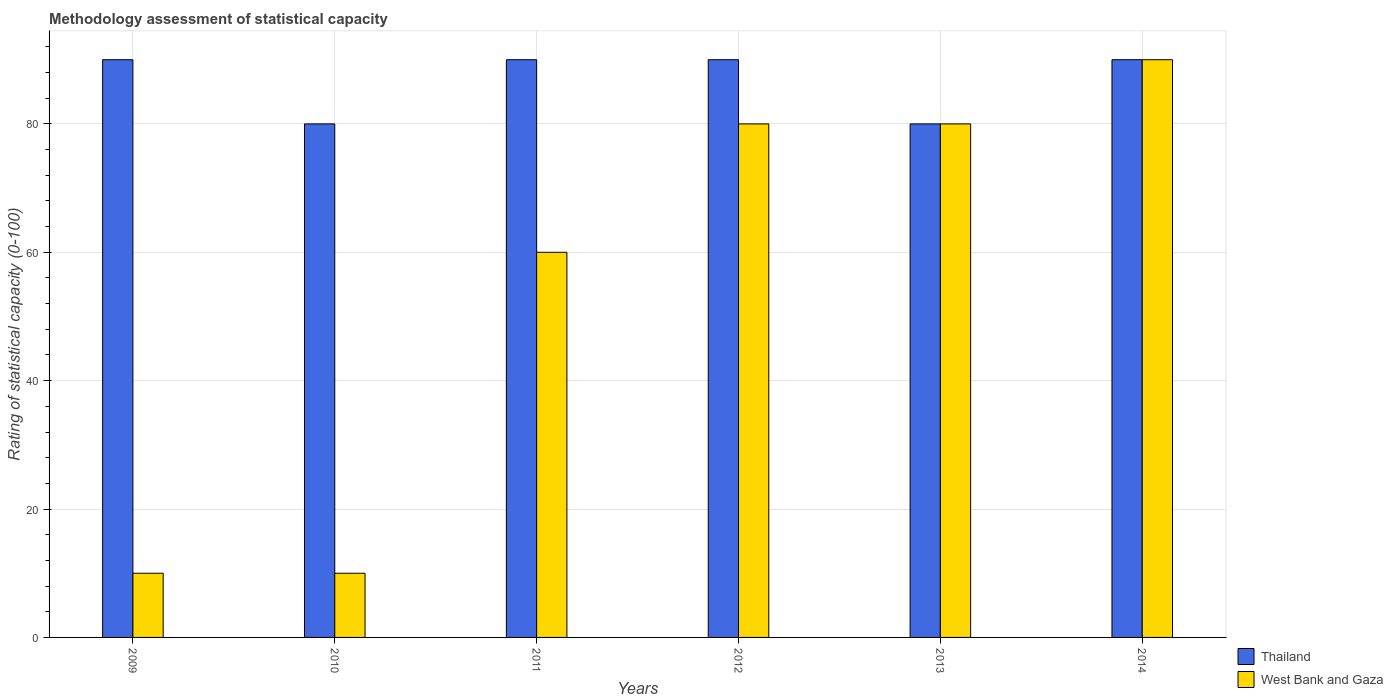Are the number of bars on each tick of the X-axis equal?
Provide a succinct answer. Yes. How many bars are there on the 2nd tick from the right?
Your answer should be very brief. 2. What is the label of the 6th group of bars from the left?
Keep it short and to the point. 2014. In how many cases, is the number of bars for a given year not equal to the number of legend labels?
Keep it short and to the point. 0. Across all years, what is the maximum rating of statistical capacity in West Bank and Gaza?
Provide a succinct answer. 90. Across all years, what is the minimum rating of statistical capacity in Thailand?
Your response must be concise. 80. In which year was the rating of statistical capacity in West Bank and Gaza maximum?
Ensure brevity in your answer.  2014. In which year was the rating of statistical capacity in Thailand minimum?
Provide a short and direct response. 2010. What is the total rating of statistical capacity in Thailand in the graph?
Make the answer very short. 520. What is the difference between the rating of statistical capacity in West Bank and Gaza in 2009 and that in 2013?
Give a very brief answer. -70. What is the ratio of the rating of statistical capacity in West Bank and Gaza in 2009 to that in 2011?
Provide a short and direct response. 0.17. Is the difference between the rating of statistical capacity in Thailand in 2010 and 2014 greater than the difference between the rating of statistical capacity in West Bank and Gaza in 2010 and 2014?
Offer a very short reply. Yes. What is the difference between the highest and the lowest rating of statistical capacity in Thailand?
Your answer should be compact. 10. What does the 2nd bar from the left in 2014 represents?
Offer a very short reply. West Bank and Gaza. What does the 2nd bar from the right in 2010 represents?
Keep it short and to the point. Thailand. How many years are there in the graph?
Offer a terse response. 6. What is the difference between two consecutive major ticks on the Y-axis?
Offer a very short reply. 20. Are the values on the major ticks of Y-axis written in scientific E-notation?
Your response must be concise. No. Does the graph contain any zero values?
Ensure brevity in your answer.  No. Does the graph contain grids?
Ensure brevity in your answer.  Yes. Where does the legend appear in the graph?
Your answer should be compact. Bottom right. What is the title of the graph?
Give a very brief answer. Methodology assessment of statistical capacity. Does "Antigua and Barbuda" appear as one of the legend labels in the graph?
Make the answer very short. No. What is the label or title of the X-axis?
Give a very brief answer. Years. What is the label or title of the Y-axis?
Provide a succinct answer. Rating of statistical capacity (0-100). What is the Rating of statistical capacity (0-100) of West Bank and Gaza in 2009?
Offer a terse response. 10. What is the Rating of statistical capacity (0-100) in Thailand in 2010?
Your answer should be compact. 80. What is the Rating of statistical capacity (0-100) in West Bank and Gaza in 2010?
Your response must be concise. 10. What is the Rating of statistical capacity (0-100) in Thailand in 2011?
Your answer should be compact. 90. What is the Rating of statistical capacity (0-100) of West Bank and Gaza in 2012?
Offer a terse response. 80. What is the Rating of statistical capacity (0-100) of West Bank and Gaza in 2013?
Ensure brevity in your answer.  80. What is the Rating of statistical capacity (0-100) of West Bank and Gaza in 2014?
Offer a terse response. 90. Across all years, what is the maximum Rating of statistical capacity (0-100) of Thailand?
Your response must be concise. 90. Across all years, what is the minimum Rating of statistical capacity (0-100) of Thailand?
Give a very brief answer. 80. What is the total Rating of statistical capacity (0-100) of Thailand in the graph?
Ensure brevity in your answer.  520. What is the total Rating of statistical capacity (0-100) of West Bank and Gaza in the graph?
Make the answer very short. 330. What is the difference between the Rating of statistical capacity (0-100) in West Bank and Gaza in 2009 and that in 2012?
Your answer should be compact. -70. What is the difference between the Rating of statistical capacity (0-100) of West Bank and Gaza in 2009 and that in 2013?
Your response must be concise. -70. What is the difference between the Rating of statistical capacity (0-100) in West Bank and Gaza in 2009 and that in 2014?
Ensure brevity in your answer.  -80. What is the difference between the Rating of statistical capacity (0-100) of Thailand in 2010 and that in 2011?
Your answer should be compact. -10. What is the difference between the Rating of statistical capacity (0-100) in West Bank and Gaza in 2010 and that in 2011?
Your answer should be very brief. -50. What is the difference between the Rating of statistical capacity (0-100) in Thailand in 2010 and that in 2012?
Provide a short and direct response. -10. What is the difference between the Rating of statistical capacity (0-100) of West Bank and Gaza in 2010 and that in 2012?
Give a very brief answer. -70. What is the difference between the Rating of statistical capacity (0-100) in West Bank and Gaza in 2010 and that in 2013?
Give a very brief answer. -70. What is the difference between the Rating of statistical capacity (0-100) of West Bank and Gaza in 2010 and that in 2014?
Give a very brief answer. -80. What is the difference between the Rating of statistical capacity (0-100) in West Bank and Gaza in 2011 and that in 2013?
Ensure brevity in your answer.  -20. What is the difference between the Rating of statistical capacity (0-100) in Thailand in 2011 and that in 2014?
Your answer should be very brief. 0. What is the difference between the Rating of statistical capacity (0-100) of West Bank and Gaza in 2012 and that in 2013?
Offer a very short reply. 0. What is the difference between the Rating of statistical capacity (0-100) of Thailand in 2012 and that in 2014?
Provide a succinct answer. 0. What is the difference between the Rating of statistical capacity (0-100) of Thailand in 2013 and that in 2014?
Your answer should be very brief. -10. What is the difference between the Rating of statistical capacity (0-100) in Thailand in 2009 and the Rating of statistical capacity (0-100) in West Bank and Gaza in 2010?
Your response must be concise. 80. What is the difference between the Rating of statistical capacity (0-100) of Thailand in 2009 and the Rating of statistical capacity (0-100) of West Bank and Gaza in 2011?
Keep it short and to the point. 30. What is the difference between the Rating of statistical capacity (0-100) in Thailand in 2009 and the Rating of statistical capacity (0-100) in West Bank and Gaza in 2012?
Provide a short and direct response. 10. What is the difference between the Rating of statistical capacity (0-100) in Thailand in 2010 and the Rating of statistical capacity (0-100) in West Bank and Gaza in 2012?
Your answer should be very brief. 0. What is the difference between the Rating of statistical capacity (0-100) of Thailand in 2010 and the Rating of statistical capacity (0-100) of West Bank and Gaza in 2014?
Offer a terse response. -10. What is the difference between the Rating of statistical capacity (0-100) in Thailand in 2011 and the Rating of statistical capacity (0-100) in West Bank and Gaza in 2012?
Your answer should be compact. 10. What is the difference between the Rating of statistical capacity (0-100) in Thailand in 2012 and the Rating of statistical capacity (0-100) in West Bank and Gaza in 2013?
Provide a succinct answer. 10. What is the difference between the Rating of statistical capacity (0-100) in Thailand in 2012 and the Rating of statistical capacity (0-100) in West Bank and Gaza in 2014?
Give a very brief answer. 0. What is the difference between the Rating of statistical capacity (0-100) in Thailand in 2013 and the Rating of statistical capacity (0-100) in West Bank and Gaza in 2014?
Offer a very short reply. -10. What is the average Rating of statistical capacity (0-100) in Thailand per year?
Offer a terse response. 86.67. What is the average Rating of statistical capacity (0-100) in West Bank and Gaza per year?
Ensure brevity in your answer.  55. In the year 2009, what is the difference between the Rating of statistical capacity (0-100) in Thailand and Rating of statistical capacity (0-100) in West Bank and Gaza?
Provide a succinct answer. 80. In the year 2010, what is the difference between the Rating of statistical capacity (0-100) of Thailand and Rating of statistical capacity (0-100) of West Bank and Gaza?
Provide a short and direct response. 70. In the year 2011, what is the difference between the Rating of statistical capacity (0-100) of Thailand and Rating of statistical capacity (0-100) of West Bank and Gaza?
Provide a succinct answer. 30. What is the ratio of the Rating of statistical capacity (0-100) in Thailand in 2009 to that in 2010?
Keep it short and to the point. 1.12. What is the ratio of the Rating of statistical capacity (0-100) of Thailand in 2009 to that in 2011?
Your answer should be very brief. 1. What is the ratio of the Rating of statistical capacity (0-100) of West Bank and Gaza in 2009 to that in 2011?
Make the answer very short. 0.17. What is the ratio of the Rating of statistical capacity (0-100) of West Bank and Gaza in 2009 to that in 2012?
Make the answer very short. 0.12. What is the ratio of the Rating of statistical capacity (0-100) in Thailand in 2009 to that in 2013?
Provide a succinct answer. 1.12. What is the ratio of the Rating of statistical capacity (0-100) of West Bank and Gaza in 2009 to that in 2013?
Offer a very short reply. 0.12. What is the ratio of the Rating of statistical capacity (0-100) of Thailand in 2009 to that in 2014?
Offer a very short reply. 1. What is the ratio of the Rating of statistical capacity (0-100) of West Bank and Gaza in 2010 to that in 2011?
Your response must be concise. 0.17. What is the ratio of the Rating of statistical capacity (0-100) of Thailand in 2010 to that in 2013?
Offer a very short reply. 1. What is the ratio of the Rating of statistical capacity (0-100) of West Bank and Gaza in 2010 to that in 2013?
Keep it short and to the point. 0.12. What is the ratio of the Rating of statistical capacity (0-100) in Thailand in 2010 to that in 2014?
Give a very brief answer. 0.89. What is the ratio of the Rating of statistical capacity (0-100) in West Bank and Gaza in 2010 to that in 2014?
Your answer should be very brief. 0.11. What is the ratio of the Rating of statistical capacity (0-100) in Thailand in 2011 to that in 2013?
Offer a very short reply. 1.12. What is the ratio of the Rating of statistical capacity (0-100) of West Bank and Gaza in 2011 to that in 2013?
Provide a succinct answer. 0.75. What is the ratio of the Rating of statistical capacity (0-100) of West Bank and Gaza in 2011 to that in 2014?
Give a very brief answer. 0.67. What is the ratio of the Rating of statistical capacity (0-100) of Thailand in 2012 to that in 2014?
Keep it short and to the point. 1. What is the ratio of the Rating of statistical capacity (0-100) in West Bank and Gaza in 2012 to that in 2014?
Give a very brief answer. 0.89. What is the ratio of the Rating of statistical capacity (0-100) of Thailand in 2013 to that in 2014?
Give a very brief answer. 0.89. What is the difference between the highest and the second highest Rating of statistical capacity (0-100) of Thailand?
Give a very brief answer. 0. What is the difference between the highest and the lowest Rating of statistical capacity (0-100) of Thailand?
Your response must be concise. 10. 